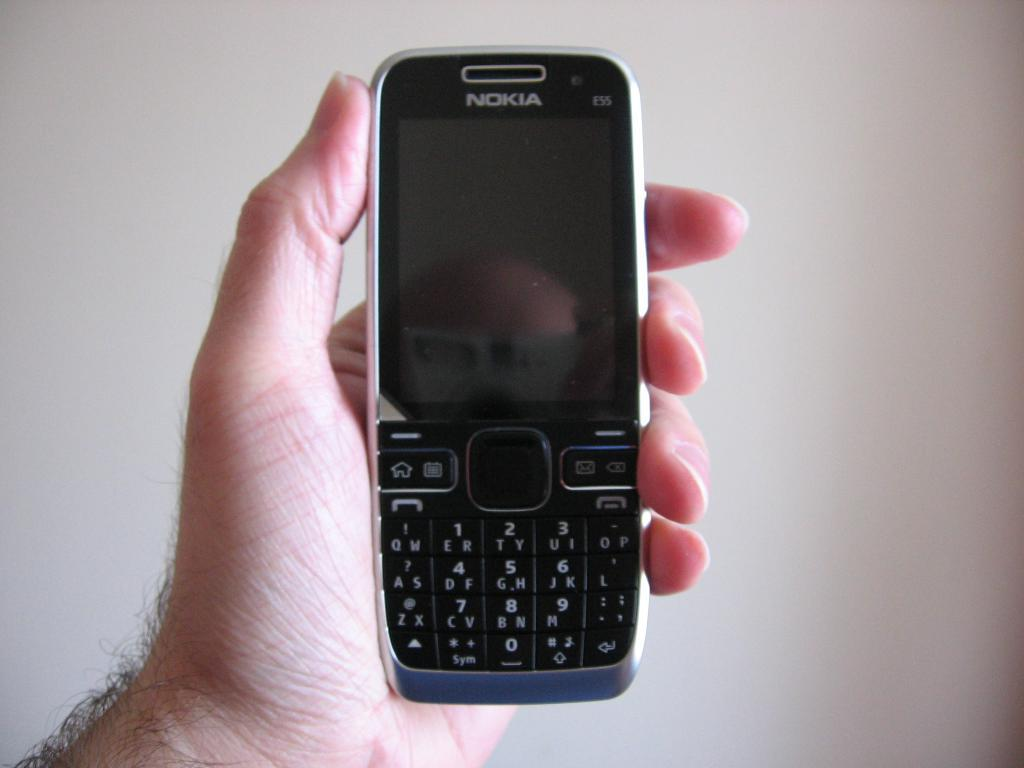<image>
Provide a brief description of the given image. A man holds a silver and black Nokia cellphone in his hand. 